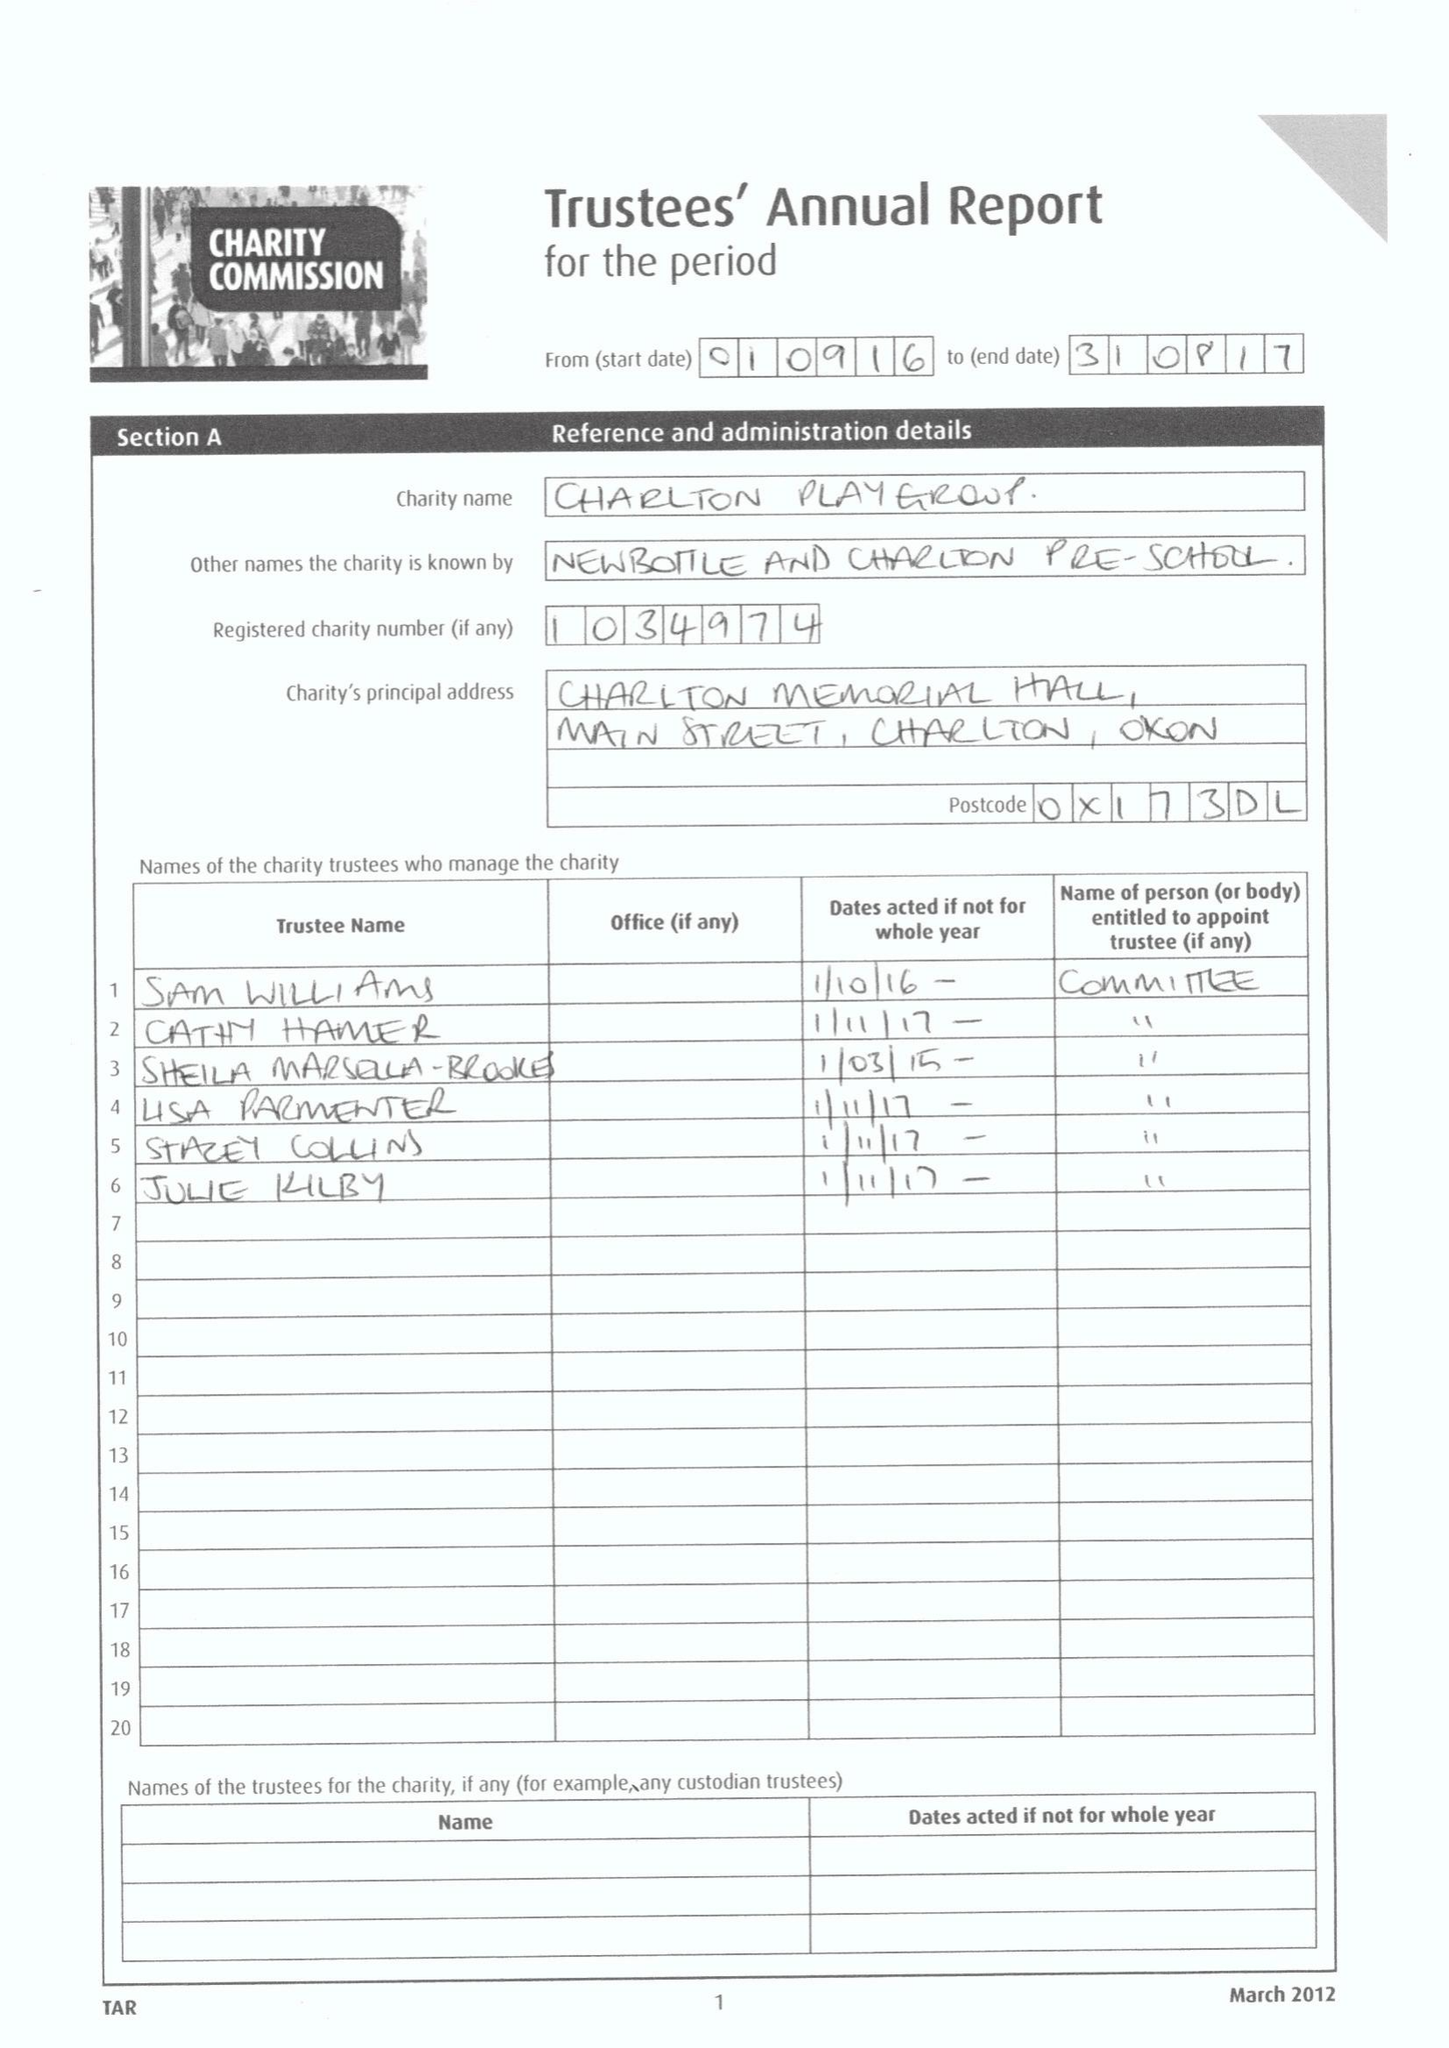What is the value for the income_annually_in_british_pounds?
Answer the question using a single word or phrase. 53331.75 